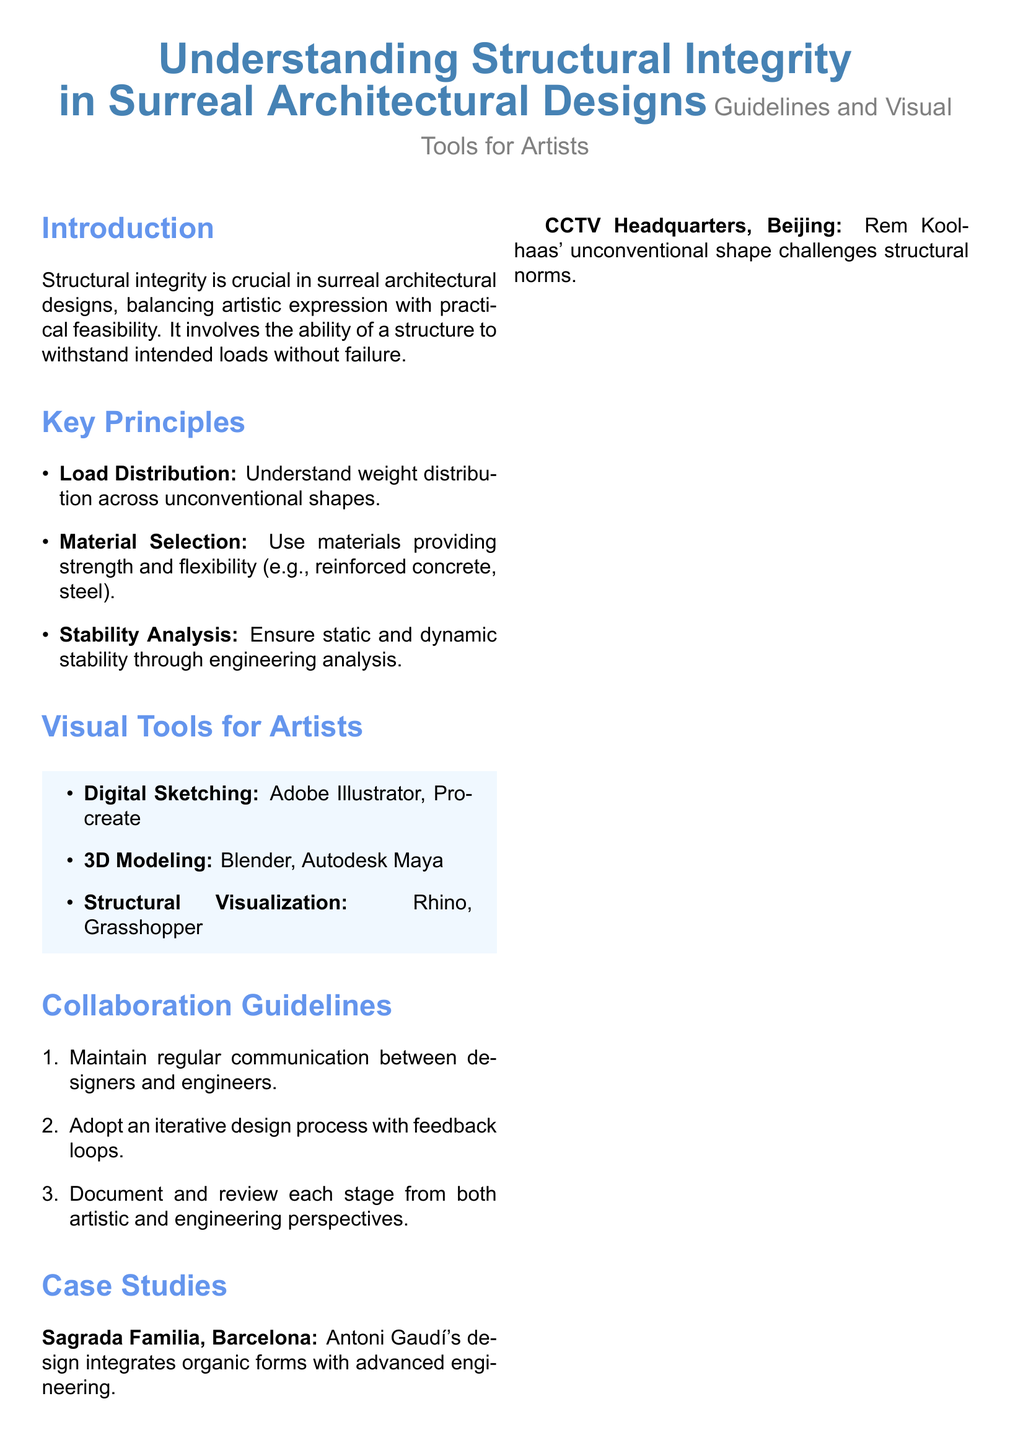What is the main focus of this user guide? The guide focuses on the importance of structural integrity in surreal architectural designs.
Answer: Structural integrity What are the three key principles listed in the document? These principles include load distribution, material selection, and stability analysis.
Answer: Load distribution, material selection, stability analysis Which architectural case study is mentioned to highlight advanced engineering? Sagrada Familia in Barcelona is cited as an example of advanced engineering integrated with organic forms.
Answer: Sagrada Familia What visual tool is recommended for 3D modeling? The document suggests using Blender or Autodesk Maya for 3D modeling.
Answer: Blender, Autodesk Maya What is one of the tips given for graphic designers? One tip suggested is to collaborate closely with civil engineers.
Answer: Collaborate closely with civil engineers How does the guide suggest handling communication between designers and engineers? It emphasizes maintaining regular communication throughout the design process.
Answer: Maintain regular communication What does the guide emphasize about being surreal? The guide states that being surreal does not imply structural impossibility.
Answer: Surreal doesn't mean structurally impossible Which software is recommended for digital sketching? Adobe Illustrator and Procreate are recommended for digital sketching.
Answer: Adobe Illustrator, Procreate 